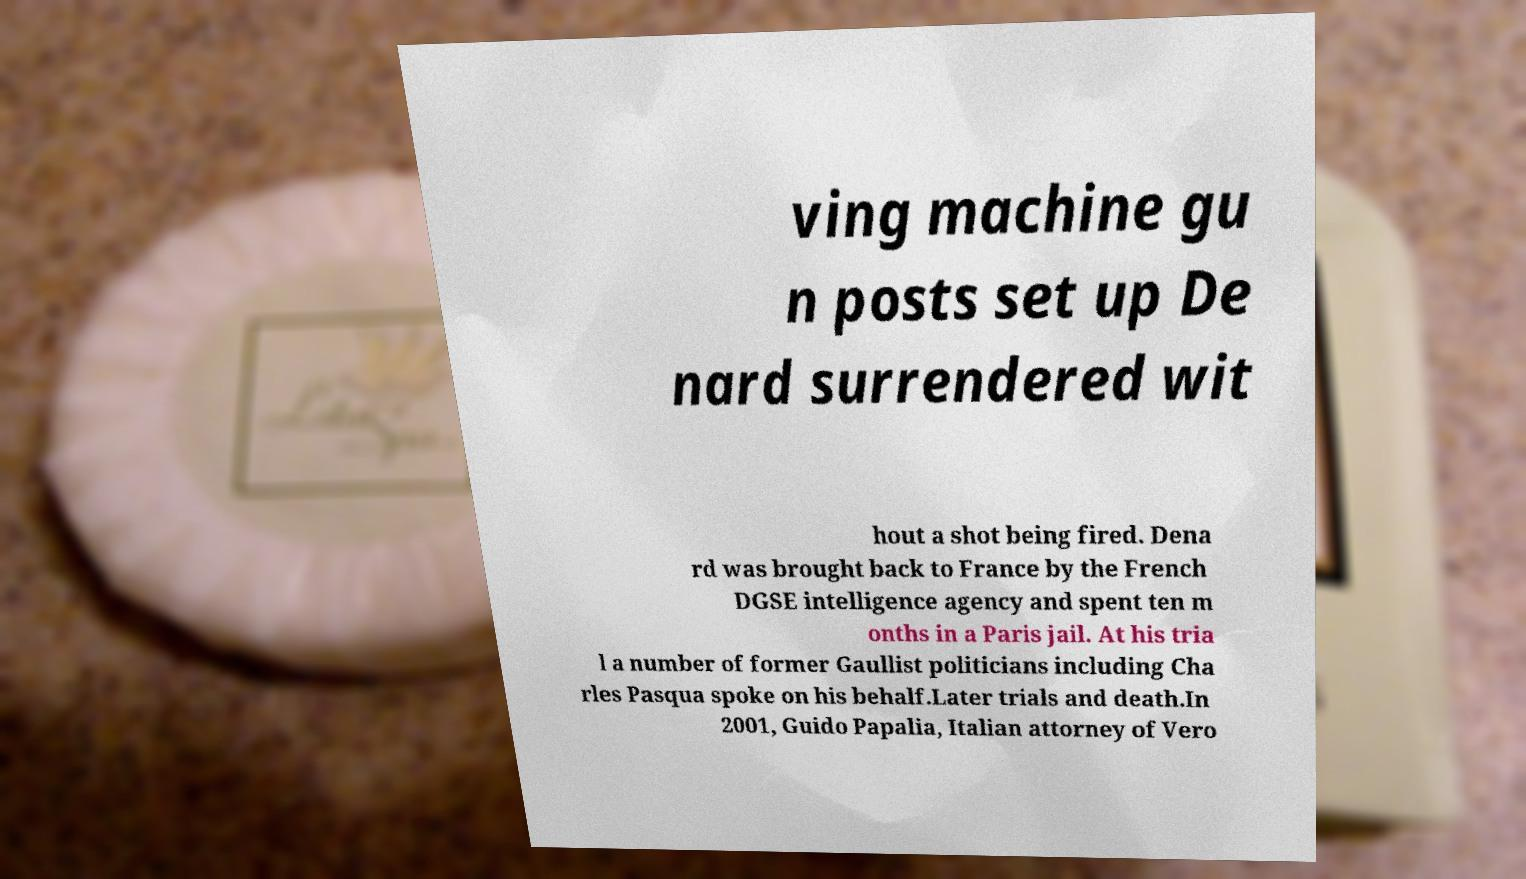Could you assist in decoding the text presented in this image and type it out clearly? ving machine gu n posts set up De nard surrendered wit hout a shot being fired. Dena rd was brought back to France by the French DGSE intelligence agency and spent ten m onths in a Paris jail. At his tria l a number of former Gaullist politicians including Cha rles Pasqua spoke on his behalf.Later trials and death.In 2001, Guido Papalia, Italian attorney of Vero 